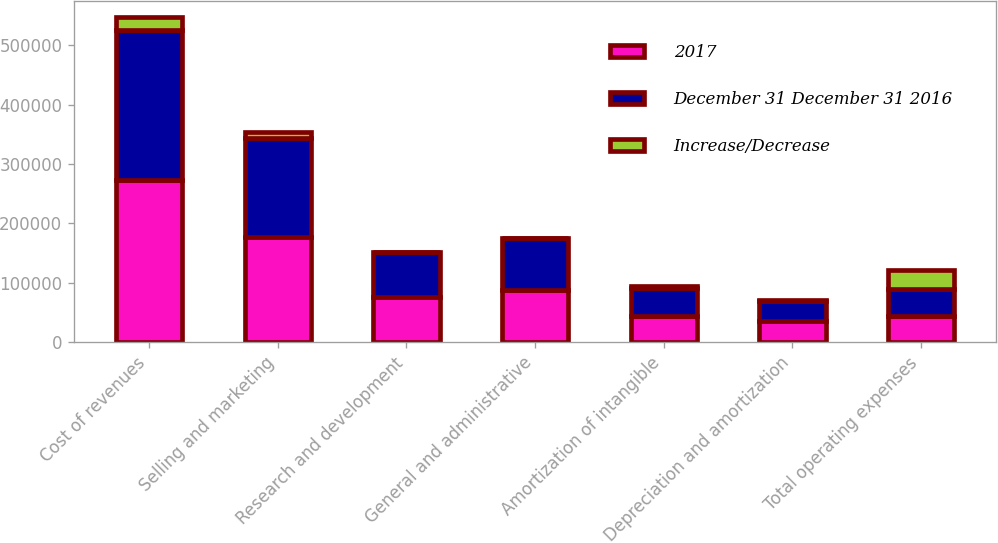Convert chart to OTSL. <chart><loc_0><loc_0><loc_500><loc_500><stacked_bar_chart><ecel><fcel>Cost of revenues<fcel>Selling and marketing<fcel>Research and development<fcel>General and administrative<fcel>Amortization of intangible<fcel>Depreciation and amortization<fcel>Total operating expenses<nl><fcel>2017<fcel>273681<fcel>177121<fcel>75849<fcel>87764<fcel>44547<fcel>35440<fcel>44547<nl><fcel>December 31 December 31 2016<fcel>252107<fcel>166666<fcel>75204<fcel>87235<fcel>47033<fcel>34320<fcel>44547<nl><fcel>Increase/Decrease<fcel>21574<fcel>10455<fcel>645<fcel>529<fcel>2486<fcel>1120<fcel>31837<nl></chart> 